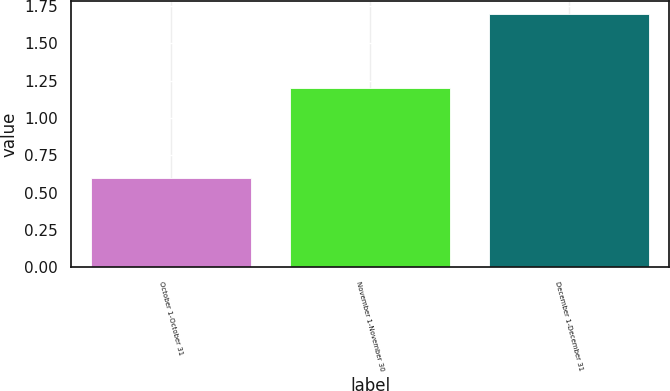Convert chart to OTSL. <chart><loc_0><loc_0><loc_500><loc_500><bar_chart><fcel>October 1-October 31<fcel>November 1-November 30<fcel>December 1-December 31<nl><fcel>0.6<fcel>1.2<fcel>1.7<nl></chart> 